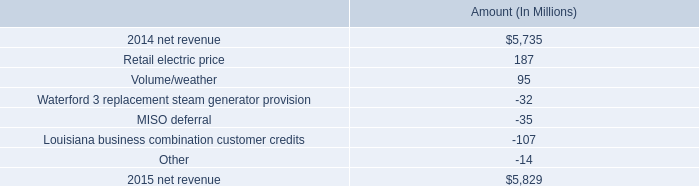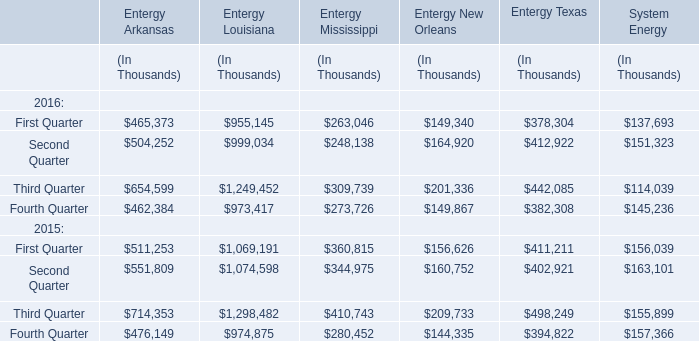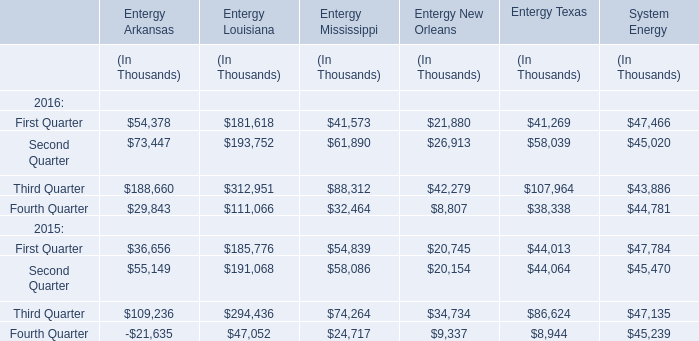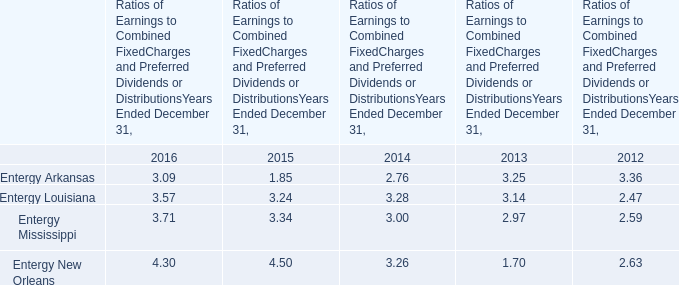what is the growth rate in net revenue in 2015 for entergy corporation? 
Computations: ((5829 - 5735) / 5735)
Answer: 0.01639. 